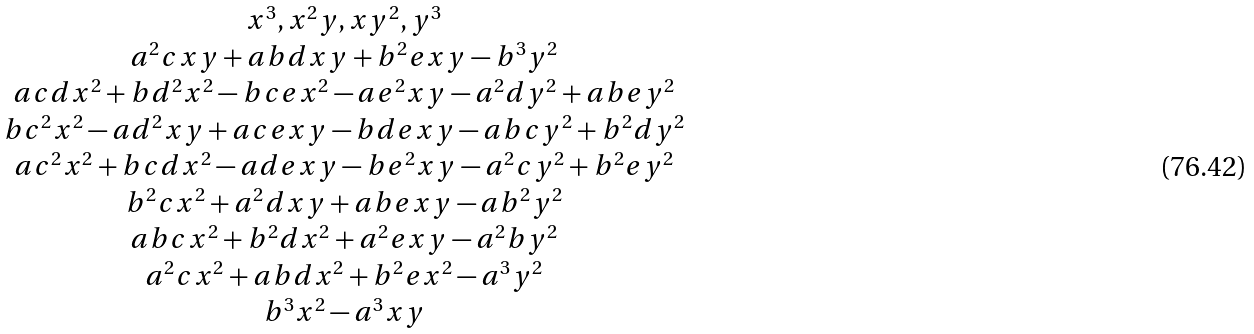Convert formula to latex. <formula><loc_0><loc_0><loc_500><loc_500>\begin{matrix} x ^ { 3 } , x ^ { 2 } y , x y ^ { 2 } , y ^ { 3 } \\ a ^ { 2 } c x y + a b d x y + b ^ { 2 } e x y - b ^ { 3 } y ^ { 2 } \\ a c d x ^ { 2 } + b d ^ { 2 } x ^ { 2 } - b c e x ^ { 2 } - a e ^ { 2 } x y - a ^ { 2 } d y ^ { 2 } + a b e y ^ { 2 } \\ b c ^ { 2 } x ^ { 2 } - a d ^ { 2 } x y + a c e x y - b d e x y - a b c y ^ { 2 } + b ^ { 2 } d y ^ { 2 } \\ a c ^ { 2 } x ^ { 2 } + b c d x ^ { 2 } - a d e x y - b e ^ { 2 } x y - a ^ { 2 } c y ^ { 2 } + b ^ { 2 } e y ^ { 2 } \\ b ^ { 2 } c x ^ { 2 } + a ^ { 2 } d x y + a b e x y - a b ^ { 2 } y ^ { 2 } \\ a b c x ^ { 2 } + b ^ { 2 } d x ^ { 2 } + a ^ { 2 } e x y - a ^ { 2 } b y ^ { 2 } \\ a ^ { 2 } c x ^ { 2 } + a b d x ^ { 2 } + b ^ { 2 } e x ^ { 2 } - a ^ { 3 } y ^ { 2 } \\ b ^ { 3 } x ^ { 2 } - a ^ { 3 } x y \\ \end{matrix}</formula> 